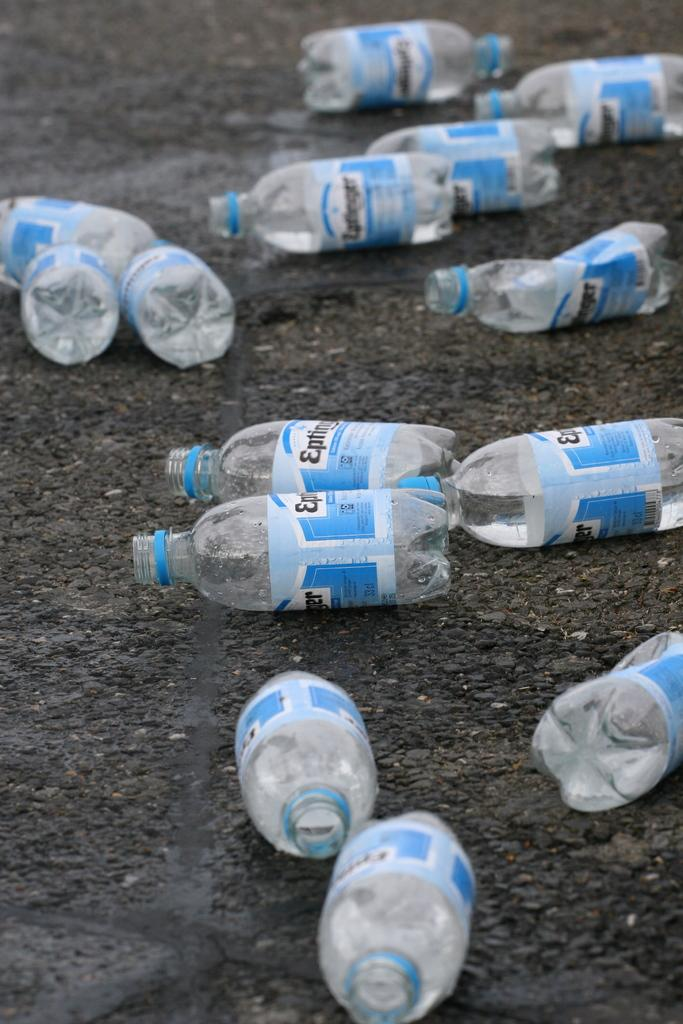Provide a one-sentence caption for the provided image. A bottle with a blue and white label with the beginning of the word EP. 